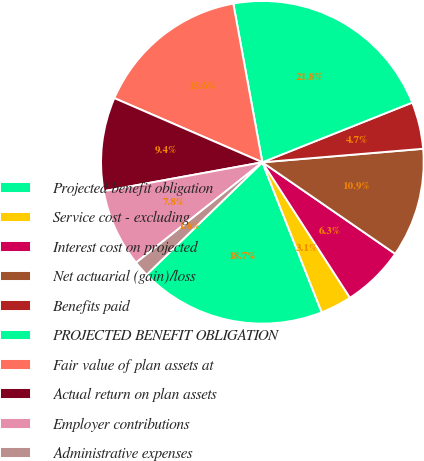Convert chart to OTSL. <chart><loc_0><loc_0><loc_500><loc_500><pie_chart><fcel>Projected benefit obligation<fcel>Service cost - excluding<fcel>Interest cost on projected<fcel>Net actuarial (gain)/loss<fcel>Benefits paid<fcel>PROJECTED BENEFIT OBLIGATION<fcel>Fair value of plan assets at<fcel>Actual return on plan assets<fcel>Employer contributions<fcel>Administrative expenses<nl><fcel>18.73%<fcel>3.14%<fcel>6.26%<fcel>10.94%<fcel>4.7%<fcel>21.85%<fcel>15.61%<fcel>9.38%<fcel>7.82%<fcel>1.58%<nl></chart> 